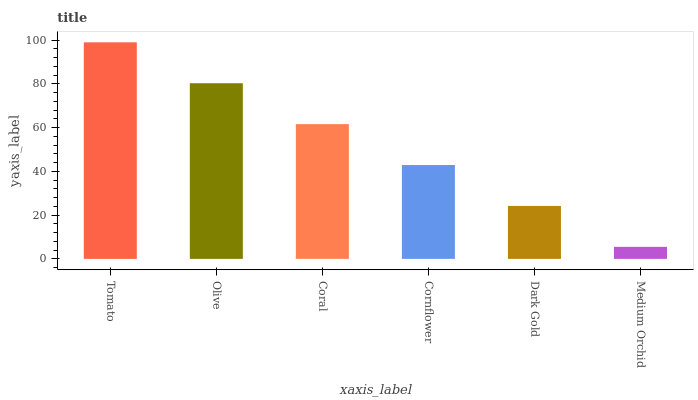Is Olive the minimum?
Answer yes or no. No. Is Olive the maximum?
Answer yes or no. No. Is Tomato greater than Olive?
Answer yes or no. Yes. Is Olive less than Tomato?
Answer yes or no. Yes. Is Olive greater than Tomato?
Answer yes or no. No. Is Tomato less than Olive?
Answer yes or no. No. Is Coral the high median?
Answer yes or no. Yes. Is Cornflower the low median?
Answer yes or no. Yes. Is Cornflower the high median?
Answer yes or no. No. Is Medium Orchid the low median?
Answer yes or no. No. 